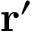Convert formula to latex. <formula><loc_0><loc_0><loc_500><loc_500>{ r ^ { \prime } }</formula> 